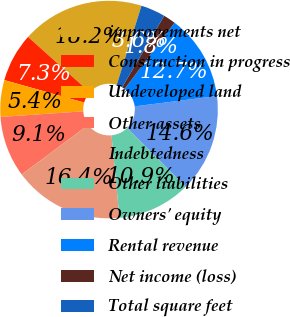Convert chart to OTSL. <chart><loc_0><loc_0><loc_500><loc_500><pie_chart><fcel>improvements net<fcel>Construction in progress<fcel>Undeveloped land<fcel>Other assets<fcel>Indebtedness<fcel>Other liabilities<fcel>Owners' equity<fcel>Rental revenue<fcel>Net income (loss)<fcel>Total square feet<nl><fcel>18.18%<fcel>7.27%<fcel>5.45%<fcel>9.09%<fcel>16.36%<fcel>10.91%<fcel>14.55%<fcel>12.73%<fcel>1.82%<fcel>3.64%<nl></chart> 